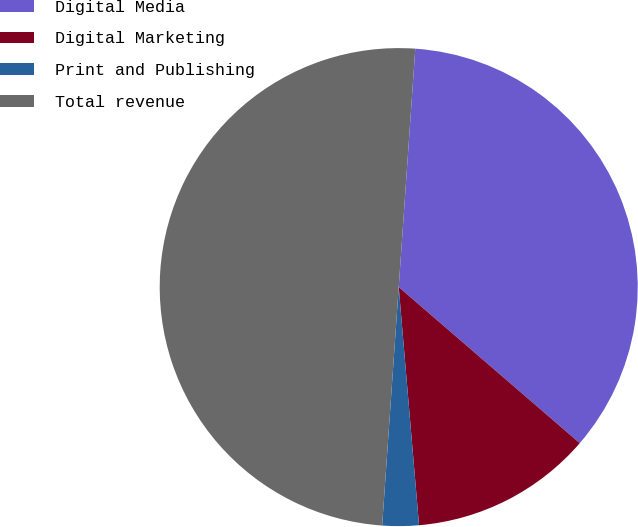Convert chart. <chart><loc_0><loc_0><loc_500><loc_500><pie_chart><fcel>Digital Media<fcel>Digital Marketing<fcel>Print and Publishing<fcel>Total revenue<nl><fcel>35.22%<fcel>12.32%<fcel>2.46%<fcel>50.0%<nl></chart> 